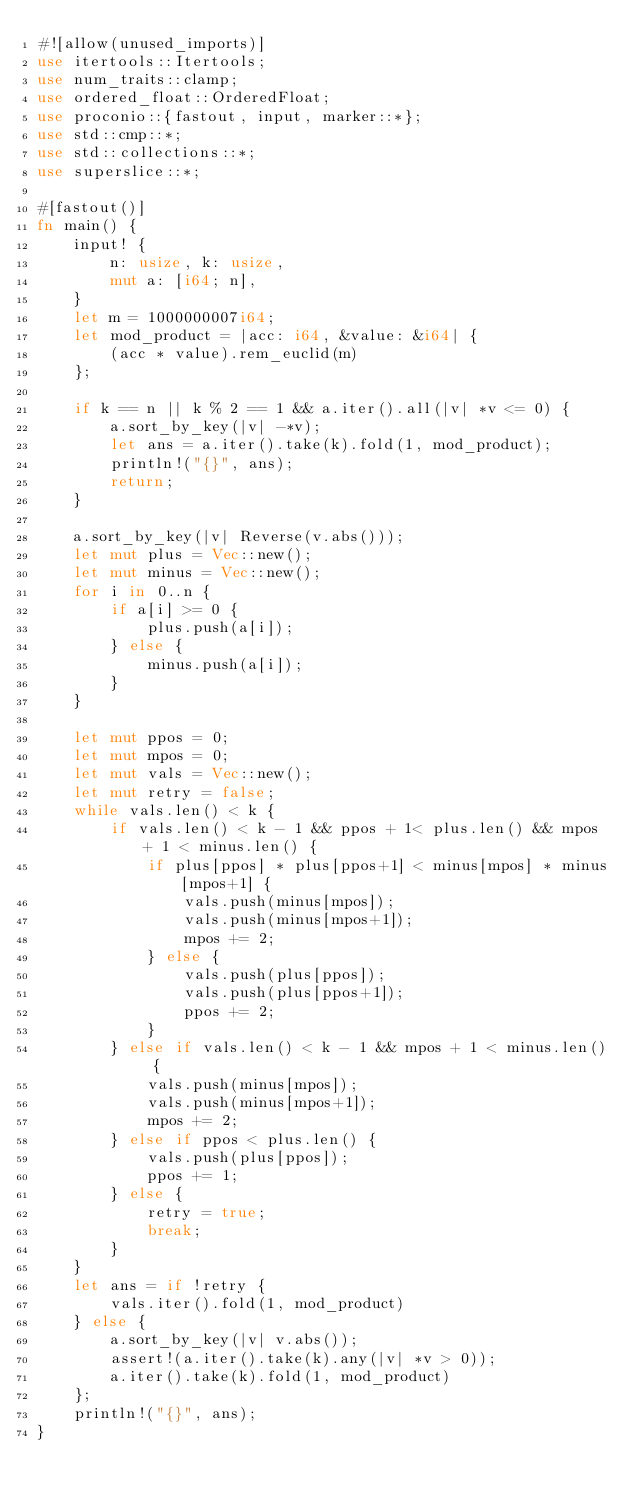Convert code to text. <code><loc_0><loc_0><loc_500><loc_500><_Rust_>#![allow(unused_imports)]
use itertools::Itertools;
use num_traits::clamp;
use ordered_float::OrderedFloat;
use proconio::{fastout, input, marker::*};
use std::cmp::*;
use std::collections::*;
use superslice::*;

#[fastout()]
fn main() {
    input! {
        n: usize, k: usize,
        mut a: [i64; n],
    }
    let m = 1000000007i64;
    let mod_product = |acc: i64, &value: &i64| {
        (acc * value).rem_euclid(m)
    };

    if k == n || k % 2 == 1 && a.iter().all(|v| *v <= 0) {
        a.sort_by_key(|v| -*v);
        let ans = a.iter().take(k).fold(1, mod_product);
        println!("{}", ans);
        return;
    }

    a.sort_by_key(|v| Reverse(v.abs()));
    let mut plus = Vec::new();
    let mut minus = Vec::new();
    for i in 0..n {
        if a[i] >= 0 {
            plus.push(a[i]);
        } else {
            minus.push(a[i]);
        }
    }

    let mut ppos = 0;
    let mut mpos = 0;
    let mut vals = Vec::new();
    let mut retry = false;
    while vals.len() < k {
        if vals.len() < k - 1 && ppos + 1< plus.len() && mpos + 1 < minus.len() {
            if plus[ppos] * plus[ppos+1] < minus[mpos] * minus[mpos+1] {
                vals.push(minus[mpos]);
                vals.push(minus[mpos+1]);
                mpos += 2;
            } else {
                vals.push(plus[ppos]);
                vals.push(plus[ppos+1]);
                ppos += 2;
            }
        } else if vals.len() < k - 1 && mpos + 1 < minus.len() {
            vals.push(minus[mpos]);
            vals.push(minus[mpos+1]);
            mpos += 2;
        } else if ppos < plus.len() {
            vals.push(plus[ppos]);
            ppos += 1;
        } else {
            retry = true;
            break;
        }
    }
    let ans = if !retry {
        vals.iter().fold(1, mod_product)
    } else {
        a.sort_by_key(|v| v.abs());
        assert!(a.iter().take(k).any(|v| *v > 0));
        a.iter().take(k).fold(1, mod_product)
    };
    println!("{}", ans);
}
</code> 